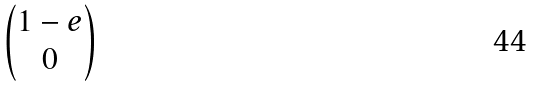Convert formula to latex. <formula><loc_0><loc_0><loc_500><loc_500>\begin{pmatrix} 1 - e \\ 0 \end{pmatrix}</formula> 